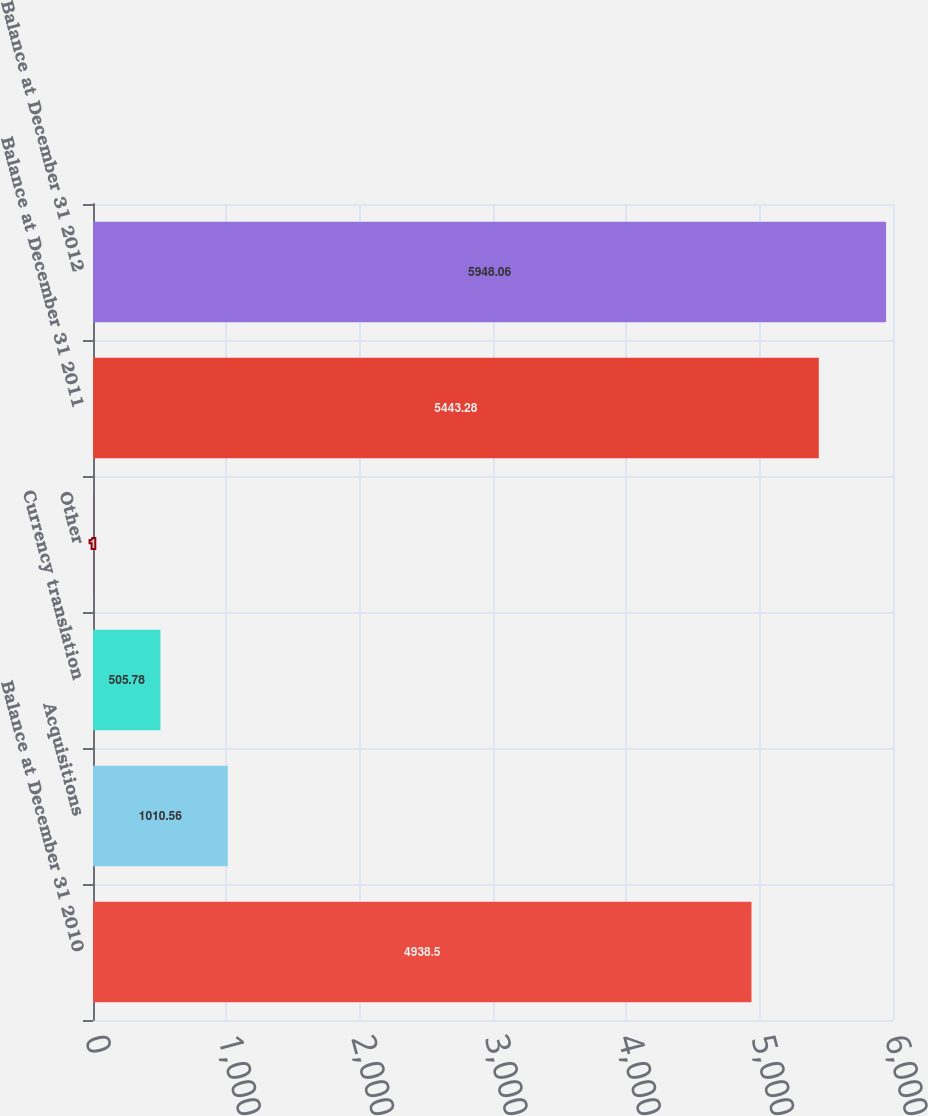Convert chart to OTSL. <chart><loc_0><loc_0><loc_500><loc_500><bar_chart><fcel>Balance at December 31 2010<fcel>Acquisitions<fcel>Currency translation<fcel>Other<fcel>Balance at December 31 2011<fcel>Balance at December 31 2012<nl><fcel>4938.5<fcel>1010.56<fcel>505.78<fcel>1<fcel>5443.28<fcel>5948.06<nl></chart> 